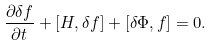<formula> <loc_0><loc_0><loc_500><loc_500>\frac { \partial \delta f } { \partial t } + [ H , \delta f ] + [ \delta \Phi , f ] = 0 .</formula> 